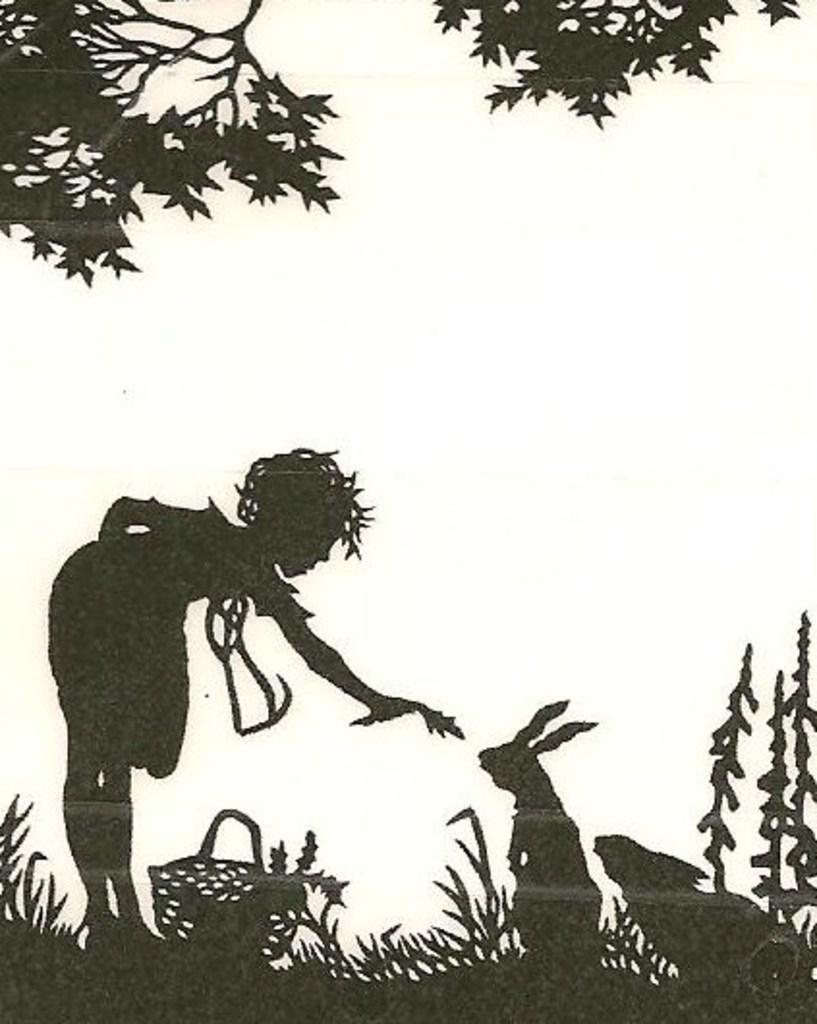Who or what is depicted in the painting? There is a person and rabbits in the painting. What objects are present in the painting? There are baskets in the painting. What type of vegetation is shown in the painting? There are plants and trees in the painting. What is the occupation of the person's daughter in the painting? There is no mention of a daughter in the painting, so it is not possible to determine her occupation. 